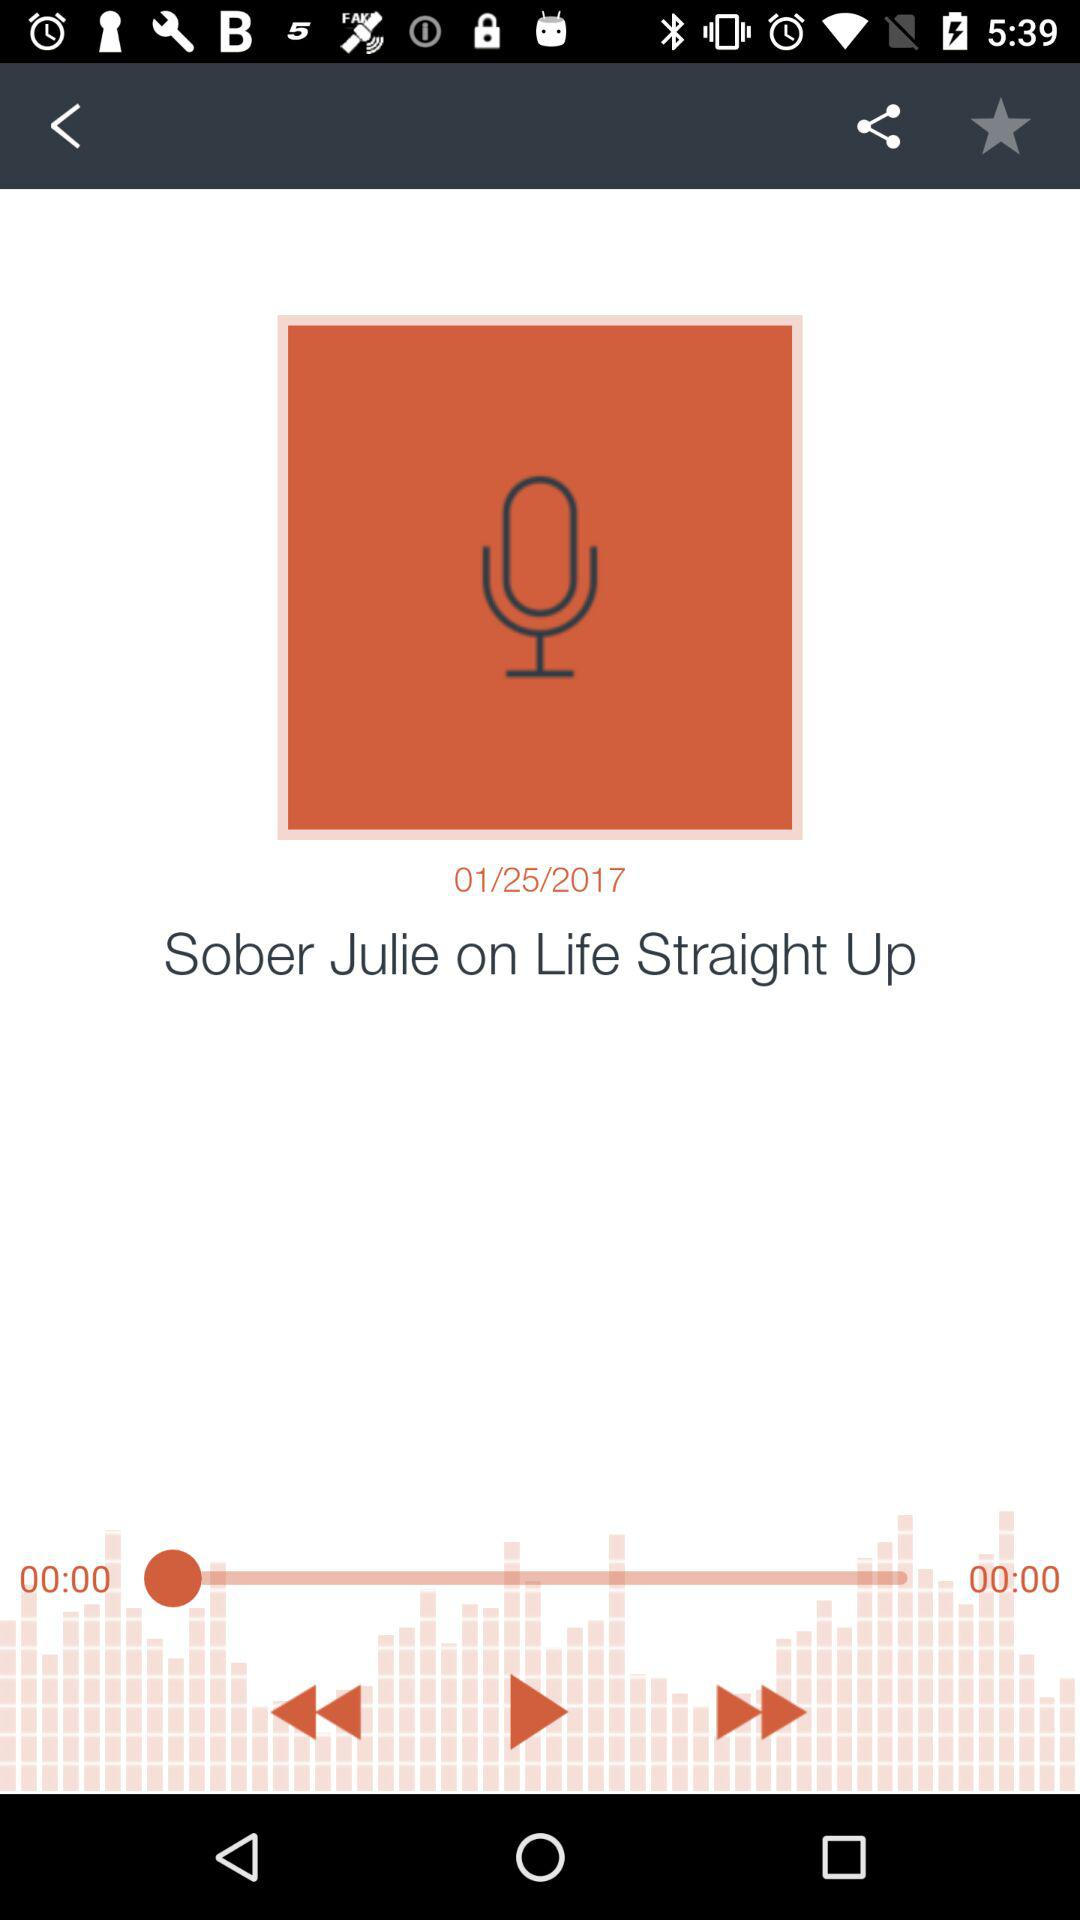What is the name of the audio? The name of the audio is "Sober Julie on Life Straight Up". 